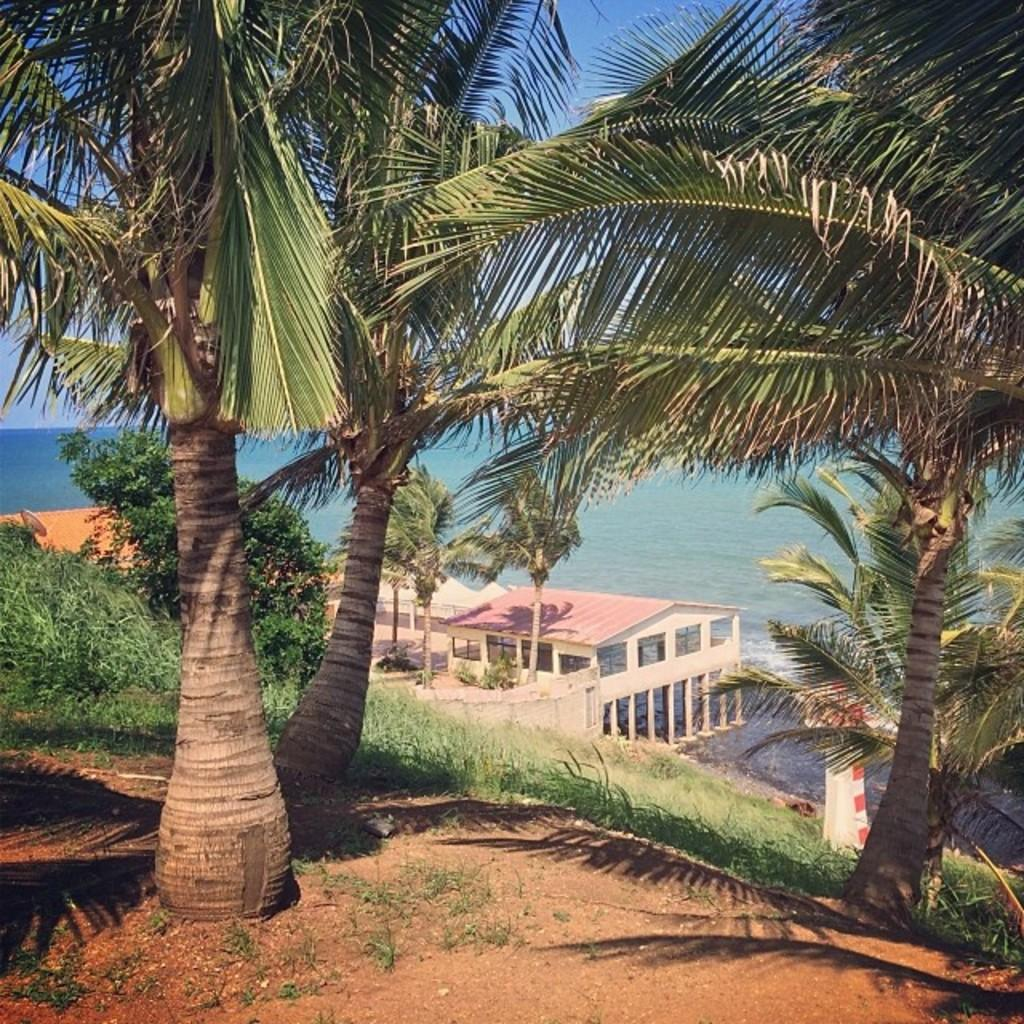What is the main setting of the image? The image depicts a sea. What structures can be seen in the image? There are buildings in the image. What type of vegetation is present in the image? There are trees in the image. What is visible at the top of the image? The sky is visible at the top of the image. What is present at the bottom of the image? Water, grass, and mud are visible at the bottom of the image. Where is the potato located in the image? There is no potato present in the image. What type of map can be seen in the image? There is no map present in the image. 